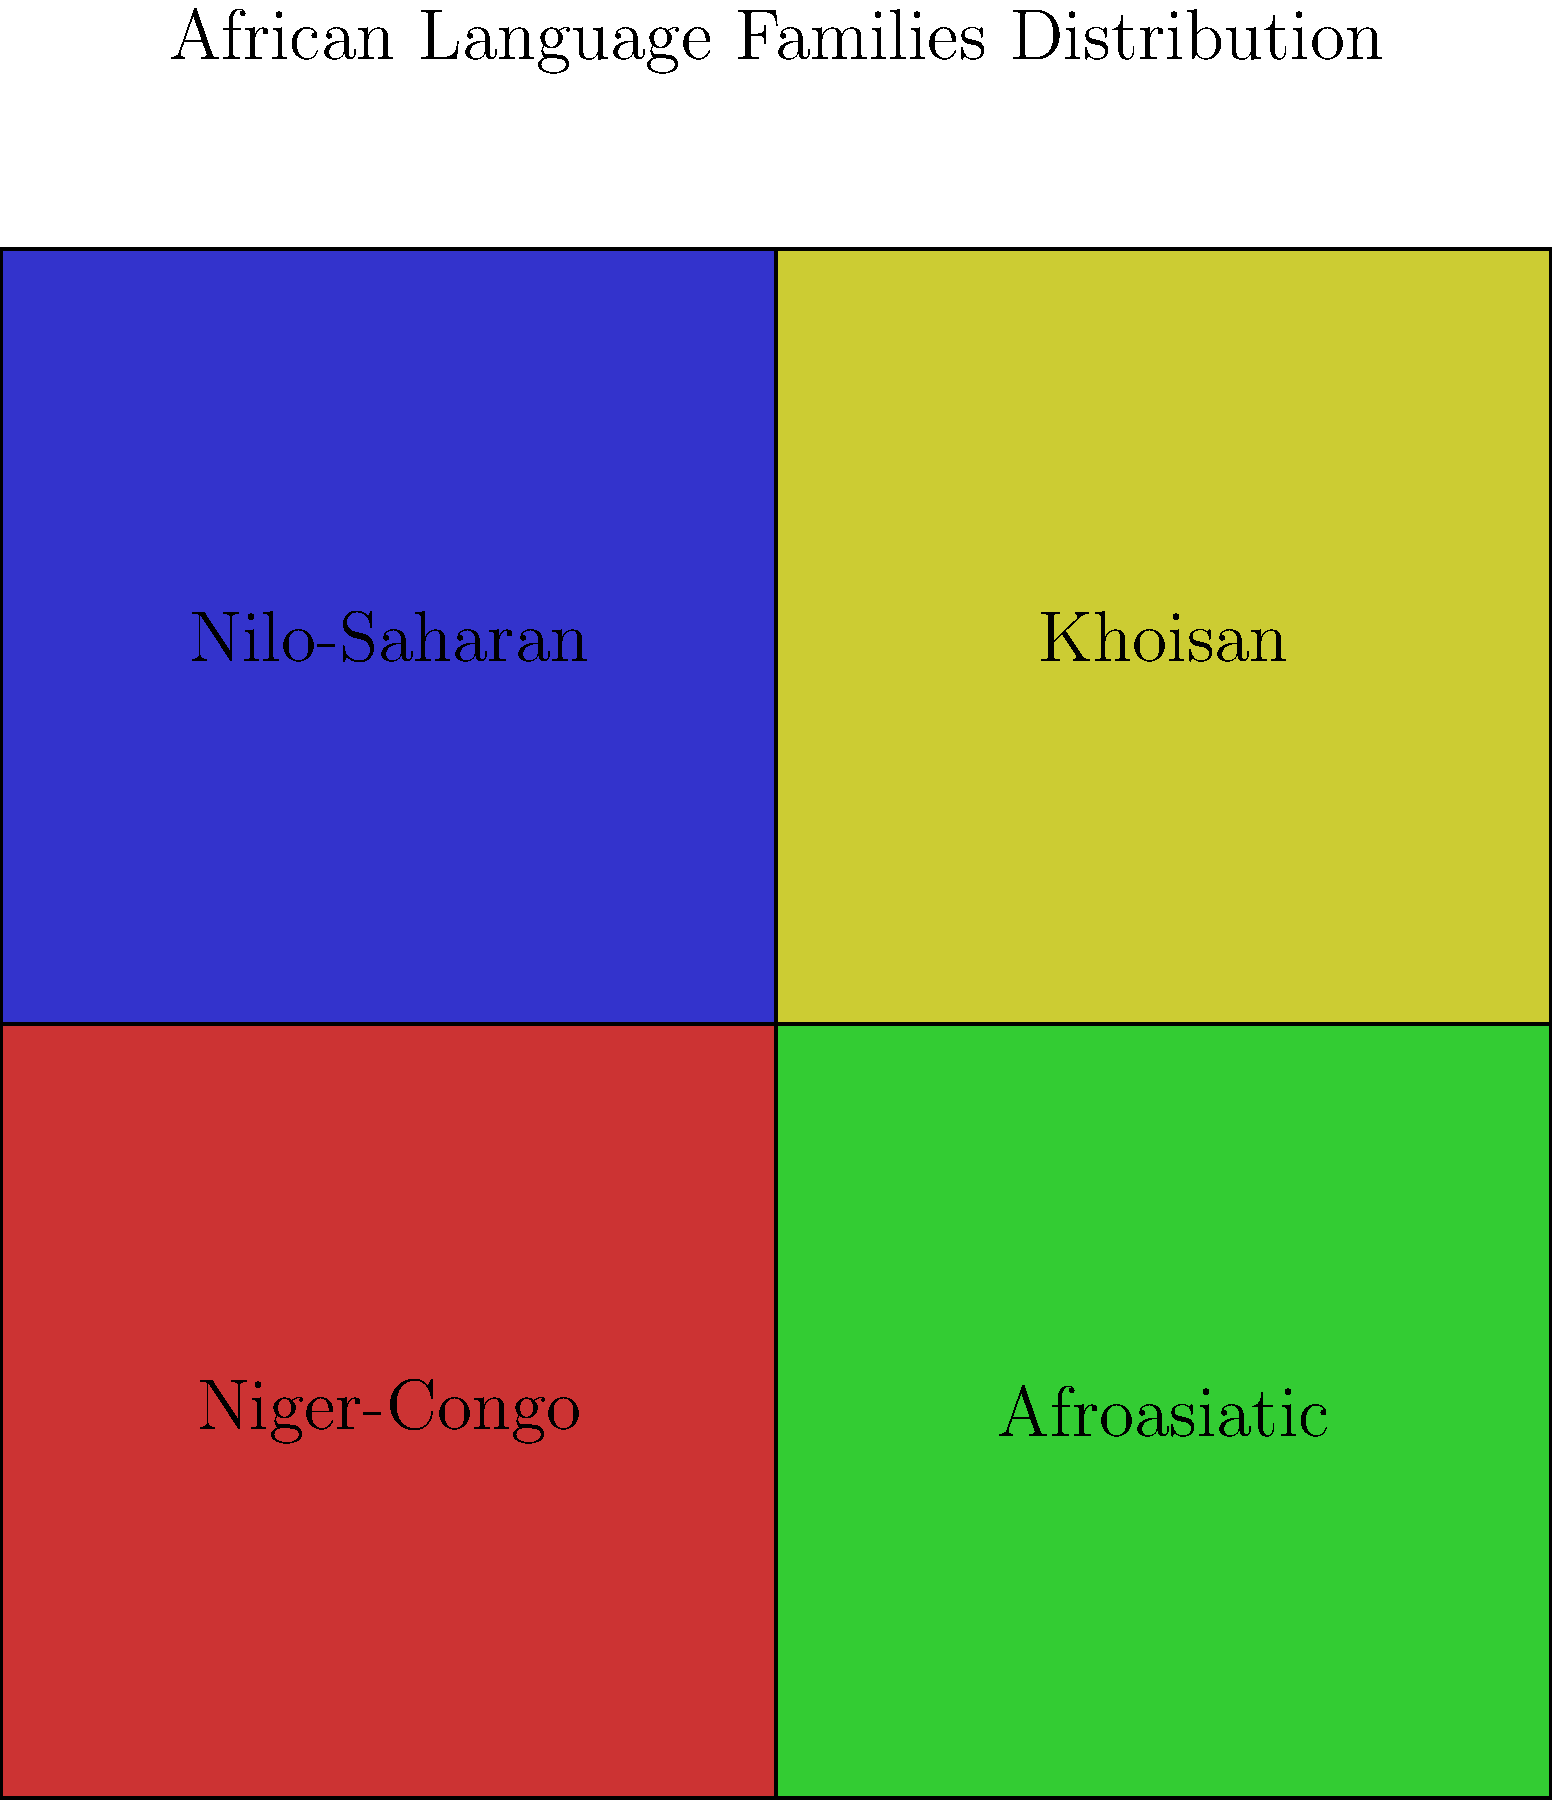Based on the language distribution map provided, which African language family is predominantly spoken in the southwestern region of the continent? To answer this question, we need to analyze the map and understand its layout:

1. The map is divided into four quadrants, each representing a major African language family.
2. The quadrants are color-coded and labeled with the names of the language families.
3. The southwestern region of Africa would correspond to the bottom-left quadrant of the map.

Step-by-step analysis:
1. Identify the quadrants:
   - Top-left: Niger-Congo (red)
   - Top-right: Afroasiatic (green)
   - Bottom-left: Nilo-Saharan (blue)
   - Bottom-right: Khoisan (yellow)

2. Locate the southwestern region:
   The southwestern region of Africa corresponds to the bottom-left quadrant of the map.

3. Identify the language family in the bottom-left quadrant:
   The bottom-left quadrant is labeled "Nilo-Saharan" and is colored blue.

Therefore, according to this simplified map, the African language family predominantly spoken in the southwestern region of the continent is Nilo-Saharan.
Answer: Nilo-Saharan 